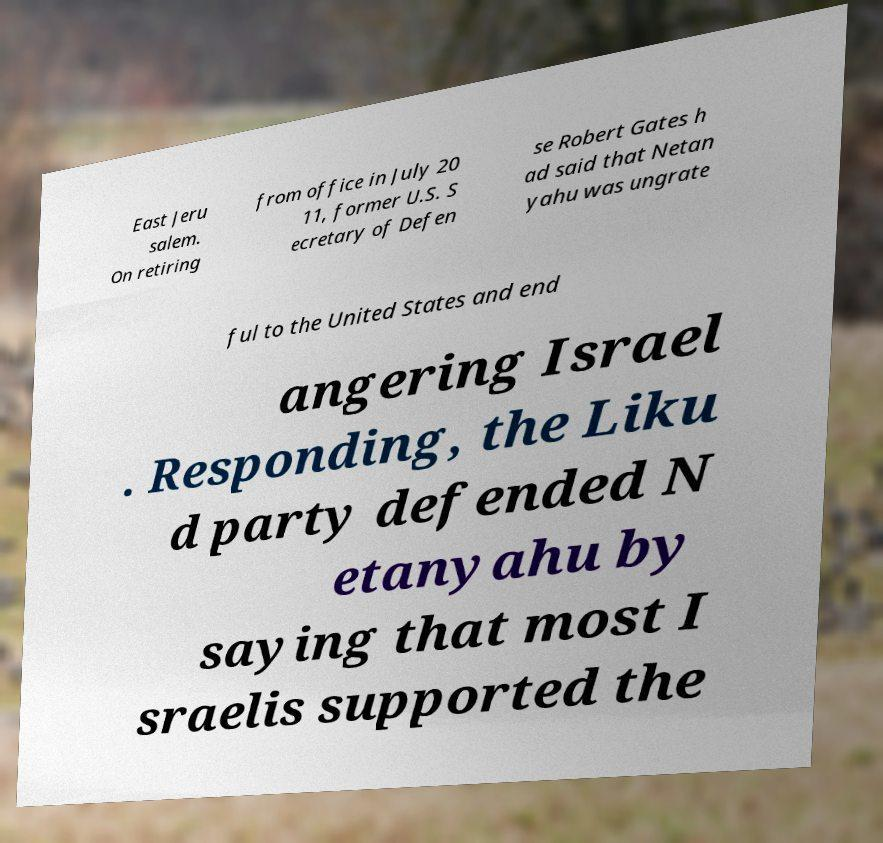Can you accurately transcribe the text from the provided image for me? East Jeru salem. On retiring from office in July 20 11, former U.S. S ecretary of Defen se Robert Gates h ad said that Netan yahu was ungrate ful to the United States and end angering Israel . Responding, the Liku d party defended N etanyahu by saying that most I sraelis supported the 